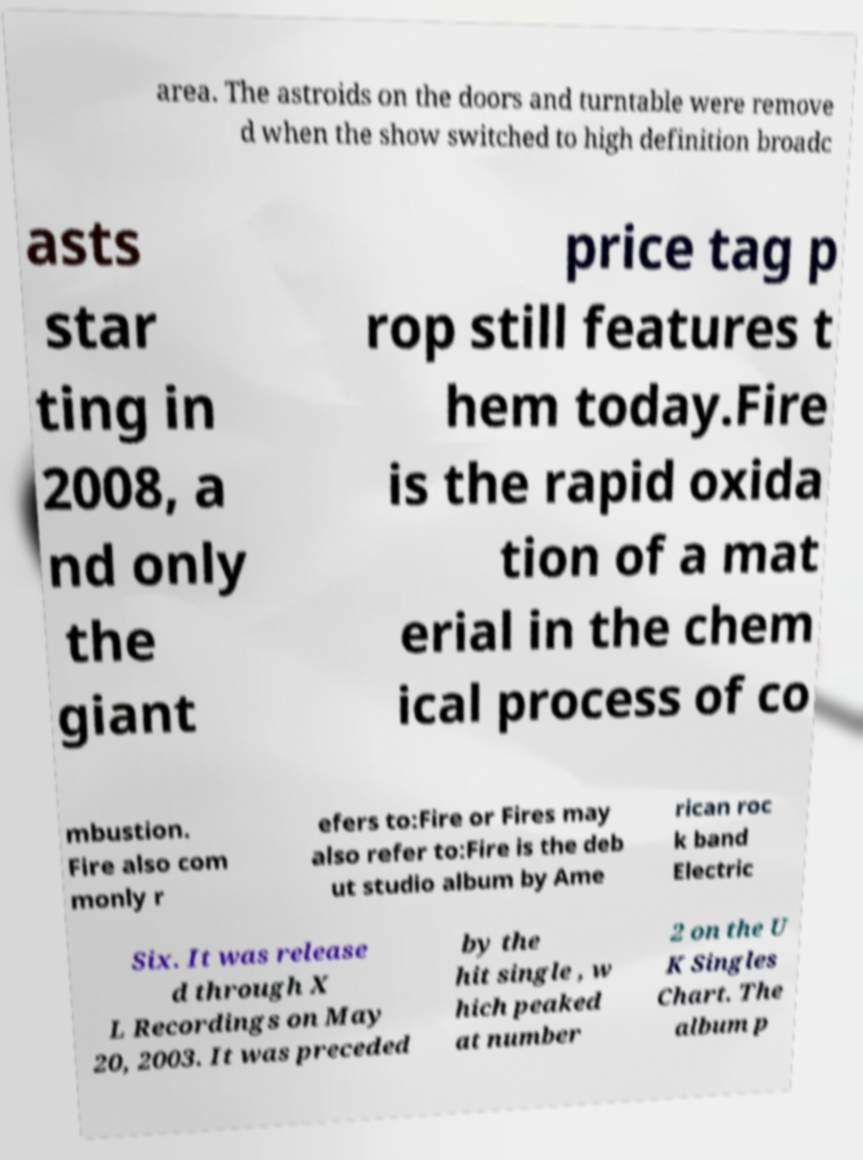Please read and relay the text visible in this image. What does it say? area. The astroids on the doors and turntable were remove d when the show switched to high definition broadc asts star ting in 2008, a nd only the giant price tag p rop still features t hem today.Fire is the rapid oxida tion of a mat erial in the chem ical process of co mbustion. Fire also com monly r efers to:Fire or Fires may also refer to:Fire is the deb ut studio album by Ame rican roc k band Electric Six. It was release d through X L Recordings on May 20, 2003. It was preceded by the hit single , w hich peaked at number 2 on the U K Singles Chart. The album p 